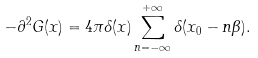Convert formula to latex. <formula><loc_0><loc_0><loc_500><loc_500>- \partial ^ { 2 } G ( x ) = 4 \pi \delta ( x ) \sum _ { n = - \infty } ^ { + \infty } \delta ( x _ { 0 } - n \beta ) .</formula> 